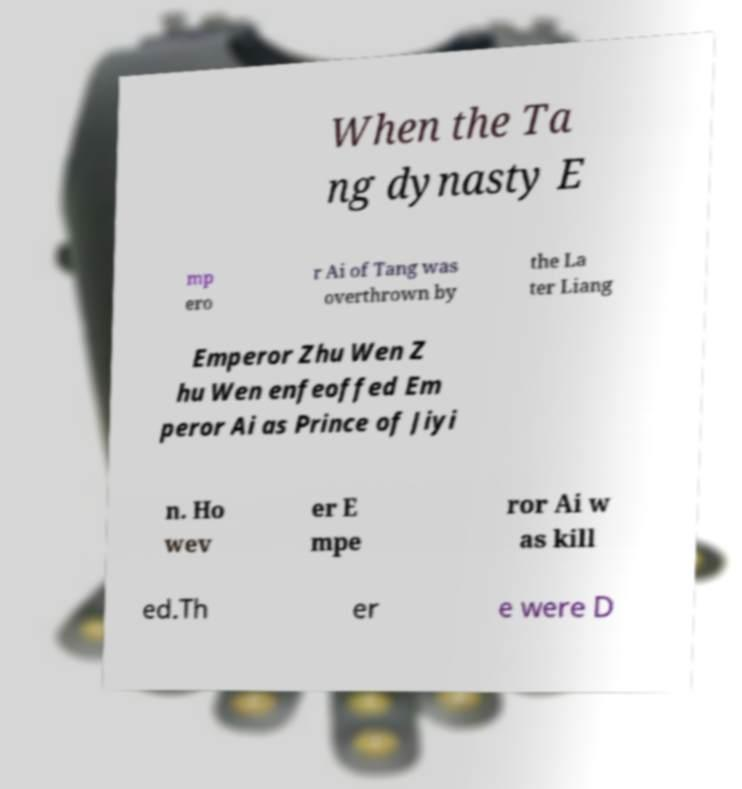Please read and relay the text visible in this image. What does it say? When the Ta ng dynasty E mp ero r Ai of Tang was overthrown by the La ter Liang Emperor Zhu Wen Z hu Wen enfeoffed Em peror Ai as Prince of Jiyi n. Ho wev er E mpe ror Ai w as kill ed.Th er e were D 